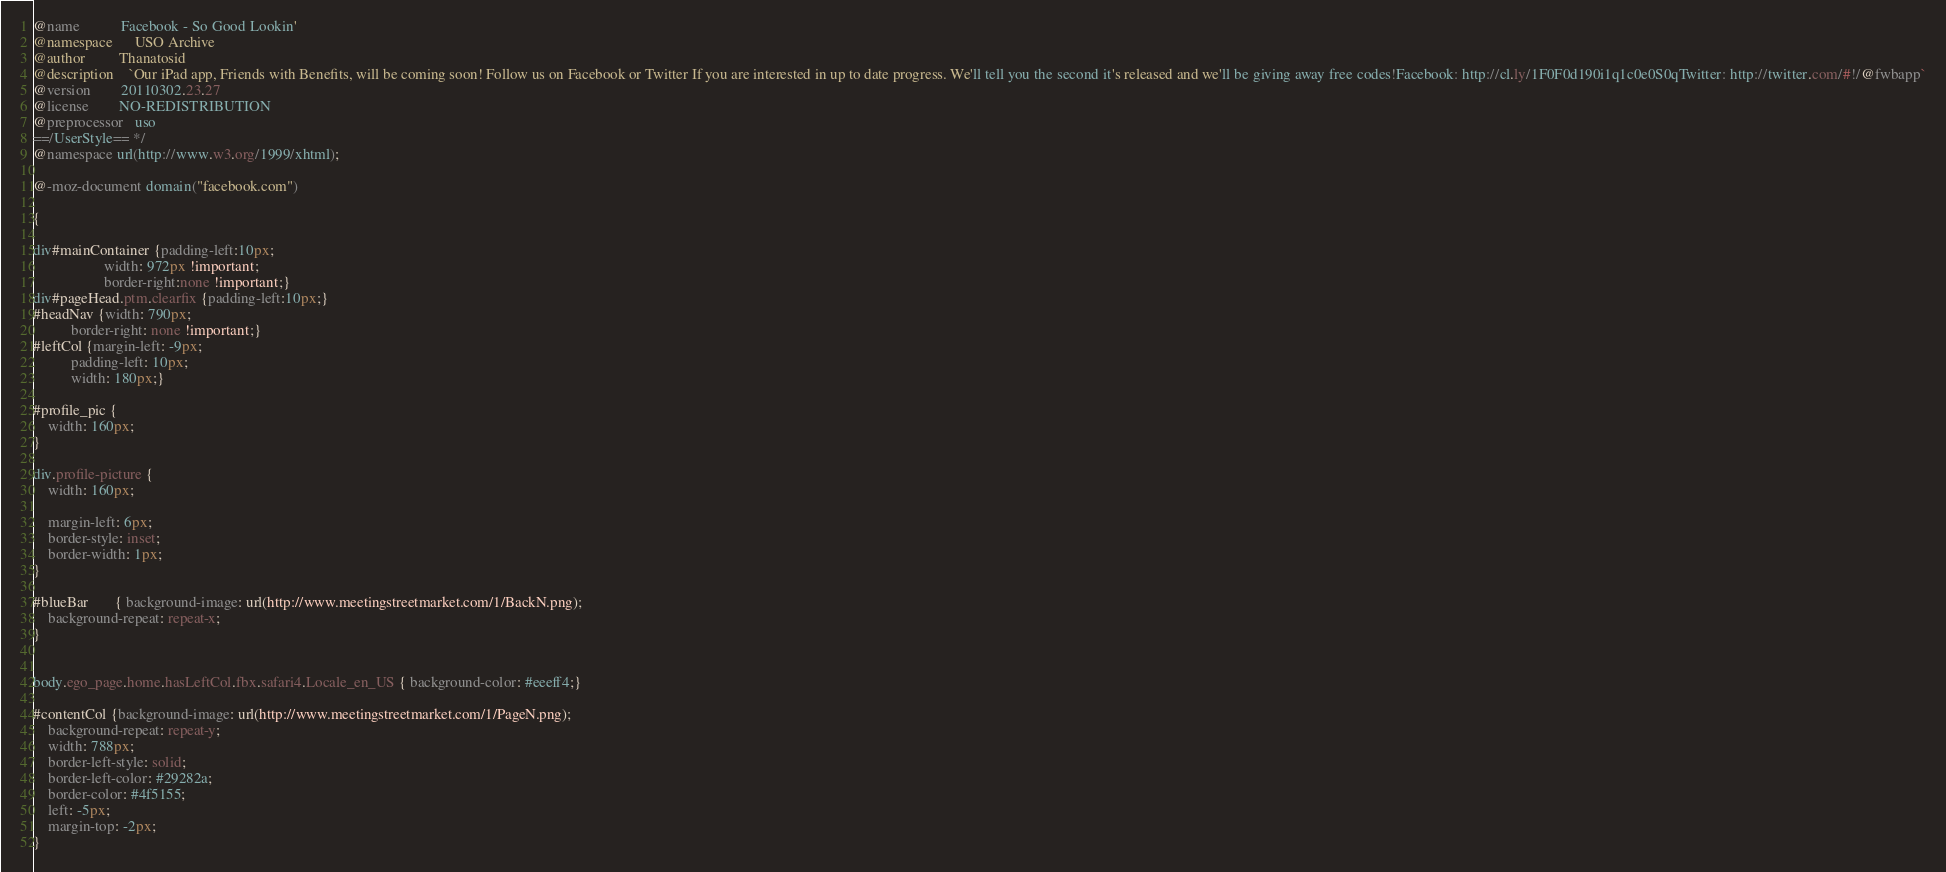<code> <loc_0><loc_0><loc_500><loc_500><_CSS_>@name           Facebook - So Good Lookin'
@namespace      USO Archive
@author         Thanatosid
@description    `Our iPad app, Friends with Benefits, will be coming soon! Follow us on Facebook or Twitter If you are interested in up to date progress. We'll tell you the second it's released and we'll be giving away free codes!Facebook: http://cl.ly/1F0F0d190i1q1c0e0S0qTwitter: http://twitter.com/#!/@fwbapp`
@version        20110302.23.27
@license        NO-REDISTRIBUTION
@preprocessor   uso
==/UserStyle== */
@namespace url(http://www.w3.org/1999/xhtml);

@-moz-document domain("facebook.com") 

{

div#mainContainer {padding-left:10px;
				   width: 972px !important;
				   border-right:none !important;}      
div#pageHead.ptm.clearfix {padding-left:10px;}
#headNav {width: 790px;
		  border-right: none !important;}
#leftCol {margin-left: -9px;
	      padding-left: 10px;
	      width: 180px;}

#profile_pic {
	width: 160px;
}

div.profile-picture {
	width: 160px;
	
	margin-left: 6px;
	border-style: inset;
	border-width: 1px;
}
	      
#blueBar       { background-image: url(http://www.meetingstreetmarket.com/1/BackN.png);
	background-repeat: repeat-x;
}


body.ego_page.home.hasLeftCol.fbx.safari4.Locale_en_US { background-color: #eeeff4;}

#contentCol {background-image: url(http://www.meetingstreetmarket.com/1/PageN.png);
	background-repeat: repeat-y;
	width: 788px;
    border-left-style: solid;
	border-left-color: #29282a;
	border-color: #4f5155;
	left: -5px;
	margin-top: -2px;
}</code> 